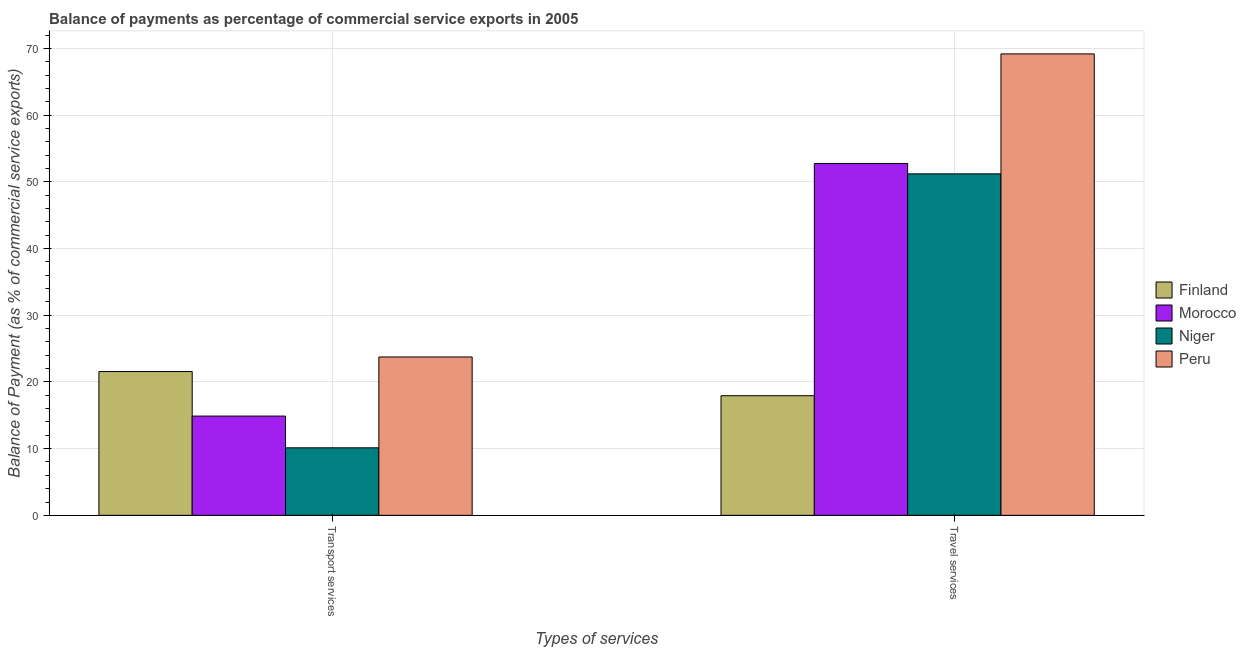How many different coloured bars are there?
Offer a terse response. 4. Are the number of bars per tick equal to the number of legend labels?
Provide a short and direct response. Yes. How many bars are there on the 2nd tick from the left?
Ensure brevity in your answer.  4. What is the label of the 2nd group of bars from the left?
Your answer should be very brief. Travel services. What is the balance of payments of travel services in Peru?
Offer a very short reply. 69.2. Across all countries, what is the maximum balance of payments of transport services?
Your response must be concise. 23.75. Across all countries, what is the minimum balance of payments of transport services?
Ensure brevity in your answer.  10.13. In which country was the balance of payments of travel services minimum?
Your answer should be compact. Finland. What is the total balance of payments of travel services in the graph?
Offer a terse response. 191.12. What is the difference between the balance of payments of transport services in Finland and that in Niger?
Provide a short and direct response. 11.43. What is the difference between the balance of payments of travel services in Morocco and the balance of payments of transport services in Peru?
Your response must be concise. 29.02. What is the average balance of payments of travel services per country?
Ensure brevity in your answer.  47.78. What is the difference between the balance of payments of travel services and balance of payments of transport services in Niger?
Make the answer very short. 41.08. What is the ratio of the balance of payments of transport services in Finland to that in Peru?
Your answer should be very brief. 0.91. Is the balance of payments of transport services in Morocco less than that in Finland?
Provide a short and direct response. Yes. In how many countries, is the balance of payments of transport services greater than the average balance of payments of transport services taken over all countries?
Offer a very short reply. 2. What does the 3rd bar from the left in Travel services represents?
Ensure brevity in your answer.  Niger. How many countries are there in the graph?
Your answer should be compact. 4. Where does the legend appear in the graph?
Provide a short and direct response. Center right. What is the title of the graph?
Your response must be concise. Balance of payments as percentage of commercial service exports in 2005. Does "Malaysia" appear as one of the legend labels in the graph?
Give a very brief answer. No. What is the label or title of the X-axis?
Your response must be concise. Types of services. What is the label or title of the Y-axis?
Give a very brief answer. Balance of Payment (as % of commercial service exports). What is the Balance of Payment (as % of commercial service exports) of Finland in Transport services?
Offer a very short reply. 21.56. What is the Balance of Payment (as % of commercial service exports) in Morocco in Transport services?
Give a very brief answer. 14.89. What is the Balance of Payment (as % of commercial service exports) of Niger in Transport services?
Offer a terse response. 10.13. What is the Balance of Payment (as % of commercial service exports) in Peru in Transport services?
Provide a short and direct response. 23.75. What is the Balance of Payment (as % of commercial service exports) of Finland in Travel services?
Offer a terse response. 17.94. What is the Balance of Payment (as % of commercial service exports) of Morocco in Travel services?
Your response must be concise. 52.77. What is the Balance of Payment (as % of commercial service exports) of Niger in Travel services?
Ensure brevity in your answer.  51.21. What is the Balance of Payment (as % of commercial service exports) in Peru in Travel services?
Keep it short and to the point. 69.2. Across all Types of services, what is the maximum Balance of Payment (as % of commercial service exports) of Finland?
Your response must be concise. 21.56. Across all Types of services, what is the maximum Balance of Payment (as % of commercial service exports) of Morocco?
Offer a terse response. 52.77. Across all Types of services, what is the maximum Balance of Payment (as % of commercial service exports) in Niger?
Your response must be concise. 51.21. Across all Types of services, what is the maximum Balance of Payment (as % of commercial service exports) in Peru?
Provide a succinct answer. 69.2. Across all Types of services, what is the minimum Balance of Payment (as % of commercial service exports) in Finland?
Offer a very short reply. 17.94. Across all Types of services, what is the minimum Balance of Payment (as % of commercial service exports) in Morocco?
Provide a succinct answer. 14.89. Across all Types of services, what is the minimum Balance of Payment (as % of commercial service exports) of Niger?
Provide a succinct answer. 10.13. Across all Types of services, what is the minimum Balance of Payment (as % of commercial service exports) of Peru?
Provide a succinct answer. 23.75. What is the total Balance of Payment (as % of commercial service exports) in Finland in the graph?
Your answer should be very brief. 39.5. What is the total Balance of Payment (as % of commercial service exports) in Morocco in the graph?
Your response must be concise. 67.66. What is the total Balance of Payment (as % of commercial service exports) of Niger in the graph?
Your response must be concise. 61.34. What is the total Balance of Payment (as % of commercial service exports) in Peru in the graph?
Ensure brevity in your answer.  92.95. What is the difference between the Balance of Payment (as % of commercial service exports) of Finland in Transport services and that in Travel services?
Keep it short and to the point. 3.62. What is the difference between the Balance of Payment (as % of commercial service exports) of Morocco in Transport services and that in Travel services?
Keep it short and to the point. -37.88. What is the difference between the Balance of Payment (as % of commercial service exports) of Niger in Transport services and that in Travel services?
Keep it short and to the point. -41.08. What is the difference between the Balance of Payment (as % of commercial service exports) in Peru in Transport services and that in Travel services?
Ensure brevity in your answer.  -45.45. What is the difference between the Balance of Payment (as % of commercial service exports) in Finland in Transport services and the Balance of Payment (as % of commercial service exports) in Morocco in Travel services?
Offer a terse response. -31.21. What is the difference between the Balance of Payment (as % of commercial service exports) in Finland in Transport services and the Balance of Payment (as % of commercial service exports) in Niger in Travel services?
Offer a terse response. -29.65. What is the difference between the Balance of Payment (as % of commercial service exports) of Finland in Transport services and the Balance of Payment (as % of commercial service exports) of Peru in Travel services?
Provide a short and direct response. -47.64. What is the difference between the Balance of Payment (as % of commercial service exports) in Morocco in Transport services and the Balance of Payment (as % of commercial service exports) in Niger in Travel services?
Offer a terse response. -36.32. What is the difference between the Balance of Payment (as % of commercial service exports) of Morocco in Transport services and the Balance of Payment (as % of commercial service exports) of Peru in Travel services?
Keep it short and to the point. -54.31. What is the difference between the Balance of Payment (as % of commercial service exports) in Niger in Transport services and the Balance of Payment (as % of commercial service exports) in Peru in Travel services?
Your answer should be very brief. -59.07. What is the average Balance of Payment (as % of commercial service exports) in Finland per Types of services?
Keep it short and to the point. 19.75. What is the average Balance of Payment (as % of commercial service exports) in Morocco per Types of services?
Your answer should be compact. 33.83. What is the average Balance of Payment (as % of commercial service exports) of Niger per Types of services?
Provide a succinct answer. 30.67. What is the average Balance of Payment (as % of commercial service exports) in Peru per Types of services?
Provide a succinct answer. 46.47. What is the difference between the Balance of Payment (as % of commercial service exports) in Finland and Balance of Payment (as % of commercial service exports) in Morocco in Transport services?
Provide a succinct answer. 6.68. What is the difference between the Balance of Payment (as % of commercial service exports) in Finland and Balance of Payment (as % of commercial service exports) in Niger in Transport services?
Your answer should be compact. 11.43. What is the difference between the Balance of Payment (as % of commercial service exports) of Finland and Balance of Payment (as % of commercial service exports) of Peru in Transport services?
Keep it short and to the point. -2.19. What is the difference between the Balance of Payment (as % of commercial service exports) in Morocco and Balance of Payment (as % of commercial service exports) in Niger in Transport services?
Your answer should be compact. 4.76. What is the difference between the Balance of Payment (as % of commercial service exports) of Morocco and Balance of Payment (as % of commercial service exports) of Peru in Transport services?
Your answer should be compact. -8.86. What is the difference between the Balance of Payment (as % of commercial service exports) in Niger and Balance of Payment (as % of commercial service exports) in Peru in Transport services?
Keep it short and to the point. -13.62. What is the difference between the Balance of Payment (as % of commercial service exports) of Finland and Balance of Payment (as % of commercial service exports) of Morocco in Travel services?
Your response must be concise. -34.83. What is the difference between the Balance of Payment (as % of commercial service exports) in Finland and Balance of Payment (as % of commercial service exports) in Niger in Travel services?
Make the answer very short. -33.27. What is the difference between the Balance of Payment (as % of commercial service exports) of Finland and Balance of Payment (as % of commercial service exports) of Peru in Travel services?
Offer a very short reply. -51.26. What is the difference between the Balance of Payment (as % of commercial service exports) in Morocco and Balance of Payment (as % of commercial service exports) in Niger in Travel services?
Make the answer very short. 1.56. What is the difference between the Balance of Payment (as % of commercial service exports) of Morocco and Balance of Payment (as % of commercial service exports) of Peru in Travel services?
Your answer should be very brief. -16.43. What is the difference between the Balance of Payment (as % of commercial service exports) of Niger and Balance of Payment (as % of commercial service exports) of Peru in Travel services?
Offer a terse response. -17.99. What is the ratio of the Balance of Payment (as % of commercial service exports) in Finland in Transport services to that in Travel services?
Provide a succinct answer. 1.2. What is the ratio of the Balance of Payment (as % of commercial service exports) of Morocco in Transport services to that in Travel services?
Keep it short and to the point. 0.28. What is the ratio of the Balance of Payment (as % of commercial service exports) of Niger in Transport services to that in Travel services?
Your response must be concise. 0.2. What is the ratio of the Balance of Payment (as % of commercial service exports) of Peru in Transport services to that in Travel services?
Provide a succinct answer. 0.34. What is the difference between the highest and the second highest Balance of Payment (as % of commercial service exports) of Finland?
Your answer should be very brief. 3.62. What is the difference between the highest and the second highest Balance of Payment (as % of commercial service exports) in Morocco?
Ensure brevity in your answer.  37.88. What is the difference between the highest and the second highest Balance of Payment (as % of commercial service exports) in Niger?
Provide a short and direct response. 41.08. What is the difference between the highest and the second highest Balance of Payment (as % of commercial service exports) of Peru?
Provide a short and direct response. 45.45. What is the difference between the highest and the lowest Balance of Payment (as % of commercial service exports) of Finland?
Provide a short and direct response. 3.62. What is the difference between the highest and the lowest Balance of Payment (as % of commercial service exports) of Morocco?
Your response must be concise. 37.88. What is the difference between the highest and the lowest Balance of Payment (as % of commercial service exports) in Niger?
Make the answer very short. 41.08. What is the difference between the highest and the lowest Balance of Payment (as % of commercial service exports) of Peru?
Offer a very short reply. 45.45. 